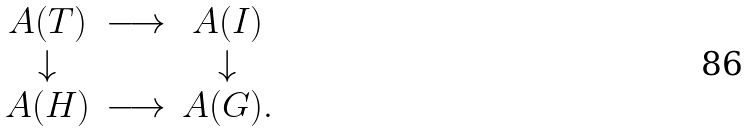<formula> <loc_0><loc_0><loc_500><loc_500>\begin{matrix} A ( T ) & \longrightarrow & A ( I ) \\ \downarrow & & \downarrow \\ A ( H ) & \longrightarrow & A ( G ) . \end{matrix}</formula> 